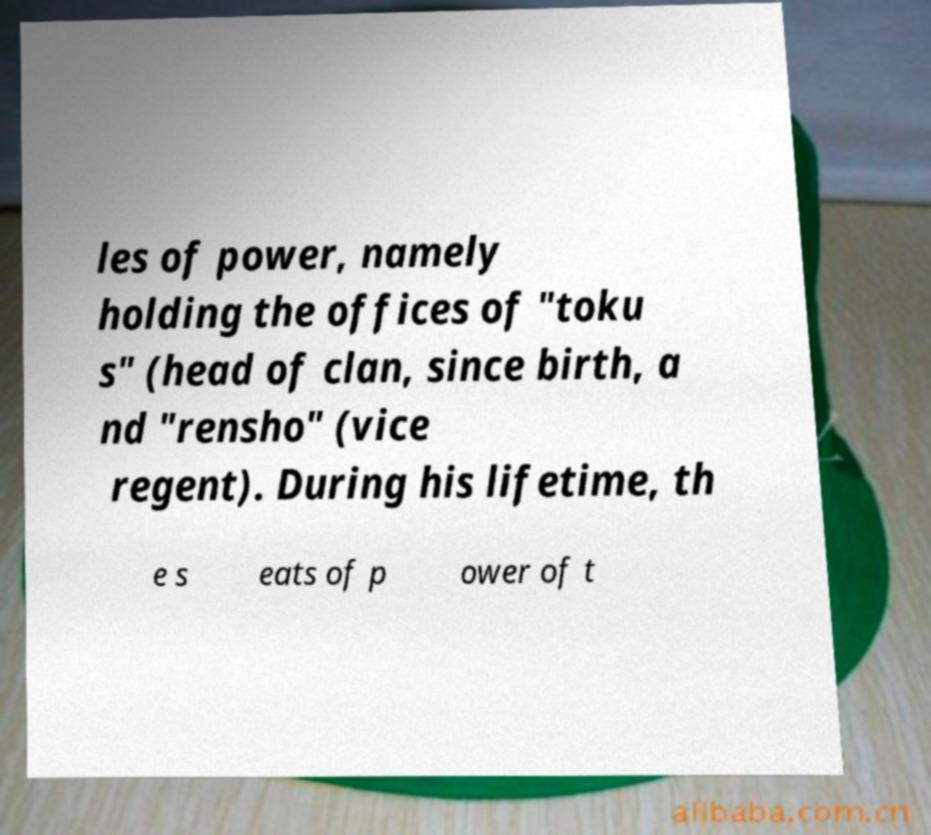I need the written content from this picture converted into text. Can you do that? les of power, namely holding the offices of "toku s" (head of clan, since birth, a nd "rensho" (vice regent). During his lifetime, th e s eats of p ower of t 